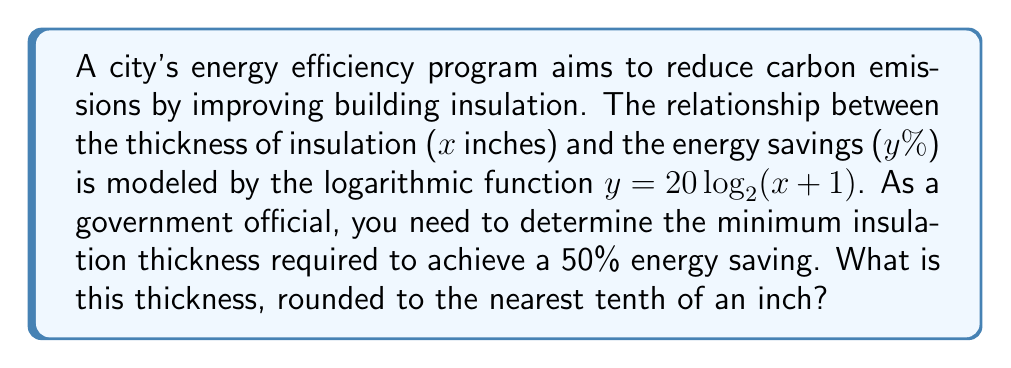Can you solve this math problem? Let's approach this step-by-step:

1) We're given the function $y = 20 \log_2(x + 1)$, where:
   $y$ is the energy savings percentage
   $x$ is the insulation thickness in inches

2) We need to find $x$ when $y = 50$. Let's substitute this:

   $50 = 20 \log_2(x + 1)$

3) Divide both sides by 20:

   $\frac{50}{20} = \log_2(x + 1)$
   $2.5 = \log_2(x + 1)$

4) To solve for $x$, we need to apply the inverse function (exponential) to both sides:

   $2^{2.5} = 2^{\log_2(x + 1)}$
   $2^{2.5} = x + 1$

5) Calculate $2^{2.5}$:

   $2^{2.5} \approx 5.6569$

6) Subtract 1 from both sides:

   $x \approx 5.6569 - 1 = 4.6569$

7) Rounding to the nearest tenth:

   $x \approx 4.7$ inches
Answer: 4.7 inches 